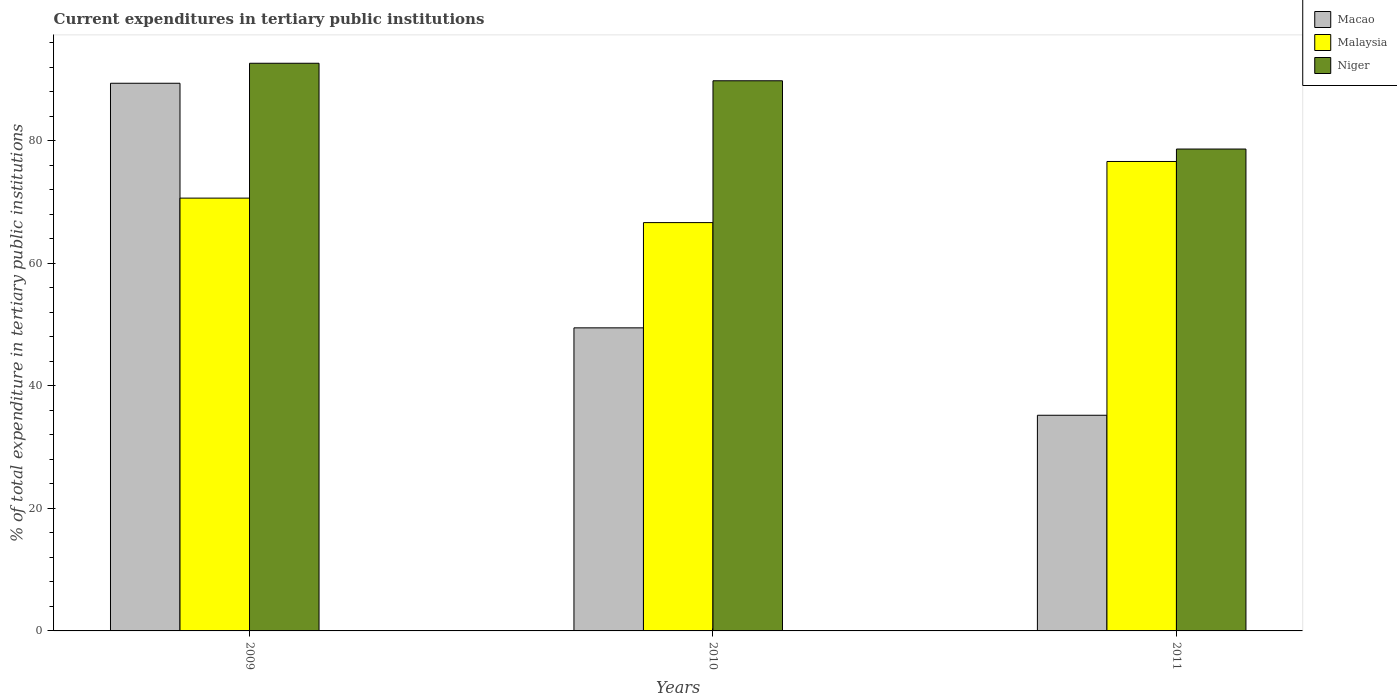How many groups of bars are there?
Your response must be concise. 3. Are the number of bars per tick equal to the number of legend labels?
Ensure brevity in your answer.  Yes. How many bars are there on the 2nd tick from the left?
Ensure brevity in your answer.  3. What is the label of the 1st group of bars from the left?
Keep it short and to the point. 2009. In how many cases, is the number of bars for a given year not equal to the number of legend labels?
Keep it short and to the point. 0. What is the current expenditures in tertiary public institutions in Niger in 2011?
Ensure brevity in your answer.  78.65. Across all years, what is the maximum current expenditures in tertiary public institutions in Malaysia?
Keep it short and to the point. 76.62. Across all years, what is the minimum current expenditures in tertiary public institutions in Niger?
Provide a succinct answer. 78.65. In which year was the current expenditures in tertiary public institutions in Niger minimum?
Give a very brief answer. 2011. What is the total current expenditures in tertiary public institutions in Niger in the graph?
Your answer should be compact. 261.11. What is the difference between the current expenditures in tertiary public institutions in Niger in 2010 and that in 2011?
Offer a very short reply. 11.14. What is the difference between the current expenditures in tertiary public institutions in Macao in 2011 and the current expenditures in tertiary public institutions in Niger in 2009?
Make the answer very short. -57.45. What is the average current expenditures in tertiary public institutions in Macao per year?
Make the answer very short. 58.02. In the year 2009, what is the difference between the current expenditures in tertiary public institutions in Niger and current expenditures in tertiary public institutions in Malaysia?
Ensure brevity in your answer.  22.01. In how many years, is the current expenditures in tertiary public institutions in Macao greater than 20 %?
Provide a short and direct response. 3. What is the ratio of the current expenditures in tertiary public institutions in Niger in 2010 to that in 2011?
Offer a very short reply. 1.14. What is the difference between the highest and the second highest current expenditures in tertiary public institutions in Macao?
Ensure brevity in your answer.  39.92. What is the difference between the highest and the lowest current expenditures in tertiary public institutions in Niger?
Give a very brief answer. 14. In how many years, is the current expenditures in tertiary public institutions in Macao greater than the average current expenditures in tertiary public institutions in Macao taken over all years?
Your answer should be compact. 1. What does the 2nd bar from the left in 2011 represents?
Ensure brevity in your answer.  Malaysia. What does the 2nd bar from the right in 2009 represents?
Provide a short and direct response. Malaysia. Is it the case that in every year, the sum of the current expenditures in tertiary public institutions in Macao and current expenditures in tertiary public institutions in Niger is greater than the current expenditures in tertiary public institutions in Malaysia?
Provide a succinct answer. Yes. How many bars are there?
Ensure brevity in your answer.  9. How many years are there in the graph?
Your response must be concise. 3. What is the difference between two consecutive major ticks on the Y-axis?
Your answer should be compact. 20. Are the values on the major ticks of Y-axis written in scientific E-notation?
Your answer should be compact. No. What is the title of the graph?
Offer a terse response. Current expenditures in tertiary public institutions. Does "Pakistan" appear as one of the legend labels in the graph?
Give a very brief answer. No. What is the label or title of the X-axis?
Offer a very short reply. Years. What is the label or title of the Y-axis?
Provide a short and direct response. % of total expenditure in tertiary public institutions. What is the % of total expenditure in tertiary public institutions of Macao in 2009?
Offer a very short reply. 89.39. What is the % of total expenditure in tertiary public institutions of Malaysia in 2009?
Ensure brevity in your answer.  70.64. What is the % of total expenditure in tertiary public institutions of Niger in 2009?
Provide a succinct answer. 92.66. What is the % of total expenditure in tertiary public institutions of Macao in 2010?
Keep it short and to the point. 49.47. What is the % of total expenditure in tertiary public institutions of Malaysia in 2010?
Provide a short and direct response. 66.65. What is the % of total expenditure in tertiary public institutions in Niger in 2010?
Provide a succinct answer. 89.8. What is the % of total expenditure in tertiary public institutions of Macao in 2011?
Give a very brief answer. 35.2. What is the % of total expenditure in tertiary public institutions of Malaysia in 2011?
Offer a very short reply. 76.62. What is the % of total expenditure in tertiary public institutions in Niger in 2011?
Ensure brevity in your answer.  78.65. Across all years, what is the maximum % of total expenditure in tertiary public institutions in Macao?
Provide a short and direct response. 89.39. Across all years, what is the maximum % of total expenditure in tertiary public institutions of Malaysia?
Offer a very short reply. 76.62. Across all years, what is the maximum % of total expenditure in tertiary public institutions of Niger?
Offer a very short reply. 92.66. Across all years, what is the minimum % of total expenditure in tertiary public institutions in Macao?
Offer a terse response. 35.2. Across all years, what is the minimum % of total expenditure in tertiary public institutions in Malaysia?
Give a very brief answer. 66.65. Across all years, what is the minimum % of total expenditure in tertiary public institutions in Niger?
Offer a very short reply. 78.65. What is the total % of total expenditure in tertiary public institutions in Macao in the graph?
Offer a terse response. 174.06. What is the total % of total expenditure in tertiary public institutions of Malaysia in the graph?
Provide a succinct answer. 213.92. What is the total % of total expenditure in tertiary public institutions of Niger in the graph?
Keep it short and to the point. 261.11. What is the difference between the % of total expenditure in tertiary public institutions of Macao in 2009 and that in 2010?
Offer a very short reply. 39.92. What is the difference between the % of total expenditure in tertiary public institutions in Malaysia in 2009 and that in 2010?
Offer a terse response. 4. What is the difference between the % of total expenditure in tertiary public institutions of Niger in 2009 and that in 2010?
Give a very brief answer. 2.86. What is the difference between the % of total expenditure in tertiary public institutions in Macao in 2009 and that in 2011?
Your answer should be compact. 54.19. What is the difference between the % of total expenditure in tertiary public institutions of Malaysia in 2009 and that in 2011?
Offer a very short reply. -5.98. What is the difference between the % of total expenditure in tertiary public institutions of Niger in 2009 and that in 2011?
Make the answer very short. 14. What is the difference between the % of total expenditure in tertiary public institutions of Macao in 2010 and that in 2011?
Offer a very short reply. 14.27. What is the difference between the % of total expenditure in tertiary public institutions in Malaysia in 2010 and that in 2011?
Provide a short and direct response. -9.98. What is the difference between the % of total expenditure in tertiary public institutions in Niger in 2010 and that in 2011?
Provide a short and direct response. 11.14. What is the difference between the % of total expenditure in tertiary public institutions in Macao in 2009 and the % of total expenditure in tertiary public institutions in Malaysia in 2010?
Your answer should be very brief. 22.75. What is the difference between the % of total expenditure in tertiary public institutions in Macao in 2009 and the % of total expenditure in tertiary public institutions in Niger in 2010?
Provide a succinct answer. -0.4. What is the difference between the % of total expenditure in tertiary public institutions of Malaysia in 2009 and the % of total expenditure in tertiary public institutions of Niger in 2010?
Your response must be concise. -19.15. What is the difference between the % of total expenditure in tertiary public institutions of Macao in 2009 and the % of total expenditure in tertiary public institutions of Malaysia in 2011?
Offer a terse response. 12.77. What is the difference between the % of total expenditure in tertiary public institutions of Macao in 2009 and the % of total expenditure in tertiary public institutions of Niger in 2011?
Make the answer very short. 10.74. What is the difference between the % of total expenditure in tertiary public institutions in Malaysia in 2009 and the % of total expenditure in tertiary public institutions in Niger in 2011?
Give a very brief answer. -8.01. What is the difference between the % of total expenditure in tertiary public institutions in Macao in 2010 and the % of total expenditure in tertiary public institutions in Malaysia in 2011?
Provide a short and direct response. -27.16. What is the difference between the % of total expenditure in tertiary public institutions of Macao in 2010 and the % of total expenditure in tertiary public institutions of Niger in 2011?
Your response must be concise. -29.18. What is the difference between the % of total expenditure in tertiary public institutions of Malaysia in 2010 and the % of total expenditure in tertiary public institutions of Niger in 2011?
Keep it short and to the point. -12.01. What is the average % of total expenditure in tertiary public institutions of Macao per year?
Your response must be concise. 58.02. What is the average % of total expenditure in tertiary public institutions of Malaysia per year?
Your response must be concise. 71.31. What is the average % of total expenditure in tertiary public institutions of Niger per year?
Offer a terse response. 87.04. In the year 2009, what is the difference between the % of total expenditure in tertiary public institutions in Macao and % of total expenditure in tertiary public institutions in Malaysia?
Your answer should be compact. 18.75. In the year 2009, what is the difference between the % of total expenditure in tertiary public institutions of Macao and % of total expenditure in tertiary public institutions of Niger?
Offer a terse response. -3.26. In the year 2009, what is the difference between the % of total expenditure in tertiary public institutions of Malaysia and % of total expenditure in tertiary public institutions of Niger?
Your response must be concise. -22.01. In the year 2010, what is the difference between the % of total expenditure in tertiary public institutions in Macao and % of total expenditure in tertiary public institutions in Malaysia?
Give a very brief answer. -17.18. In the year 2010, what is the difference between the % of total expenditure in tertiary public institutions of Macao and % of total expenditure in tertiary public institutions of Niger?
Ensure brevity in your answer.  -40.33. In the year 2010, what is the difference between the % of total expenditure in tertiary public institutions in Malaysia and % of total expenditure in tertiary public institutions in Niger?
Provide a succinct answer. -23.15. In the year 2011, what is the difference between the % of total expenditure in tertiary public institutions of Macao and % of total expenditure in tertiary public institutions of Malaysia?
Ensure brevity in your answer.  -41.42. In the year 2011, what is the difference between the % of total expenditure in tertiary public institutions in Macao and % of total expenditure in tertiary public institutions in Niger?
Make the answer very short. -43.45. In the year 2011, what is the difference between the % of total expenditure in tertiary public institutions of Malaysia and % of total expenditure in tertiary public institutions of Niger?
Keep it short and to the point. -2.03. What is the ratio of the % of total expenditure in tertiary public institutions of Macao in 2009 to that in 2010?
Provide a succinct answer. 1.81. What is the ratio of the % of total expenditure in tertiary public institutions of Malaysia in 2009 to that in 2010?
Ensure brevity in your answer.  1.06. What is the ratio of the % of total expenditure in tertiary public institutions of Niger in 2009 to that in 2010?
Your response must be concise. 1.03. What is the ratio of the % of total expenditure in tertiary public institutions of Macao in 2009 to that in 2011?
Your response must be concise. 2.54. What is the ratio of the % of total expenditure in tertiary public institutions in Malaysia in 2009 to that in 2011?
Offer a very short reply. 0.92. What is the ratio of the % of total expenditure in tertiary public institutions of Niger in 2009 to that in 2011?
Your response must be concise. 1.18. What is the ratio of the % of total expenditure in tertiary public institutions in Macao in 2010 to that in 2011?
Your answer should be compact. 1.41. What is the ratio of the % of total expenditure in tertiary public institutions of Malaysia in 2010 to that in 2011?
Keep it short and to the point. 0.87. What is the ratio of the % of total expenditure in tertiary public institutions of Niger in 2010 to that in 2011?
Provide a short and direct response. 1.14. What is the difference between the highest and the second highest % of total expenditure in tertiary public institutions in Macao?
Your response must be concise. 39.92. What is the difference between the highest and the second highest % of total expenditure in tertiary public institutions in Malaysia?
Your answer should be very brief. 5.98. What is the difference between the highest and the second highest % of total expenditure in tertiary public institutions in Niger?
Provide a short and direct response. 2.86. What is the difference between the highest and the lowest % of total expenditure in tertiary public institutions in Macao?
Ensure brevity in your answer.  54.19. What is the difference between the highest and the lowest % of total expenditure in tertiary public institutions in Malaysia?
Ensure brevity in your answer.  9.98. What is the difference between the highest and the lowest % of total expenditure in tertiary public institutions in Niger?
Offer a terse response. 14. 